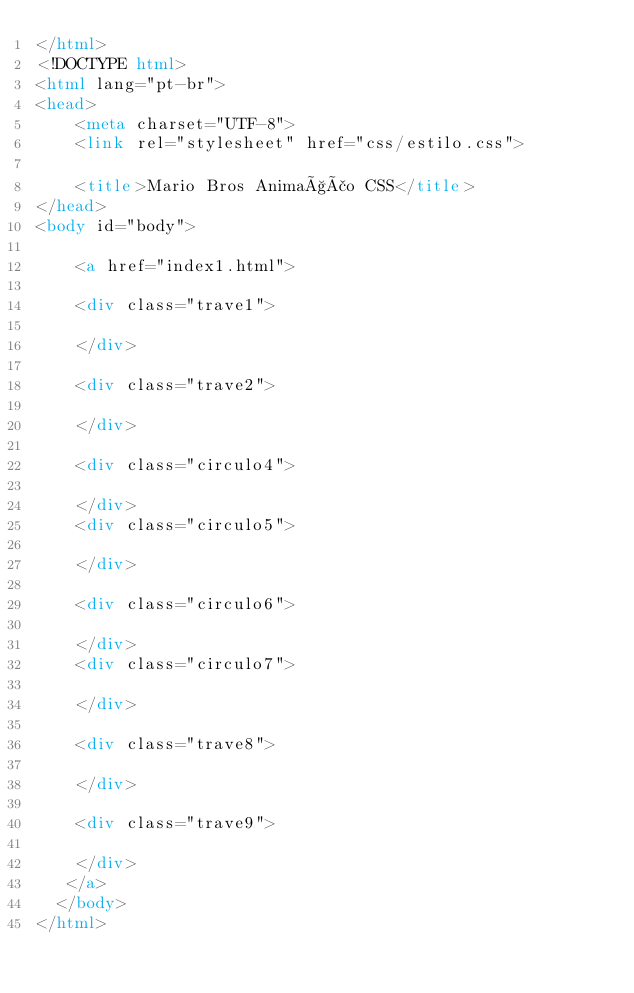<code> <loc_0><loc_0><loc_500><loc_500><_HTML_></html>
<!DOCTYPE html>
<html lang="pt-br">
<head>
    <meta charset="UTF-8">
    <link rel="stylesheet" href="css/estilo.css">
    
    <title>Mario Bros Animação CSS</title>
</head>
<body id="body">
 
    <a href="index1.html">

    <div class="trave1">
           
    </div>

    <div class="trave2">

    </div>

    <div class="circulo4">

    </div>
    <div class="circulo5">

    </div>

    <div class="circulo6">

    </div>
    <div class="circulo7">

    </div>
    
    <div class="trave8">

    </div>

    <div class="trave9">

    </div>
   </a>   
  </body>
</html></code> 